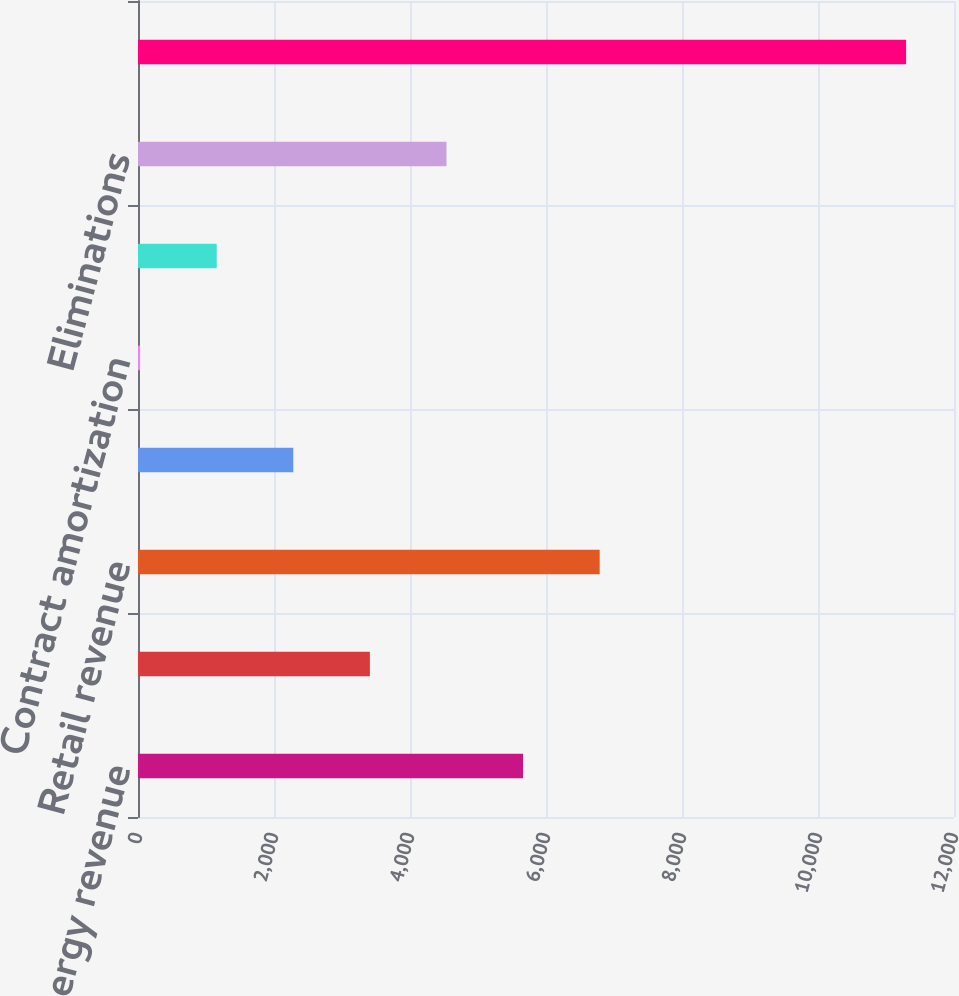Convert chart. <chart><loc_0><loc_0><loc_500><loc_500><bar_chart><fcel>Energy revenue<fcel>Capacity revenue<fcel>Retail revenue<fcel>Mark-to-market for economic<fcel>Contract amortization<fcel>Other revenues<fcel>Eliminations<fcel>Total operating revenues<nl><fcel>5663<fcel>3410.2<fcel>6789.4<fcel>2283.8<fcel>31<fcel>1157.4<fcel>4536.6<fcel>11295<nl></chart> 